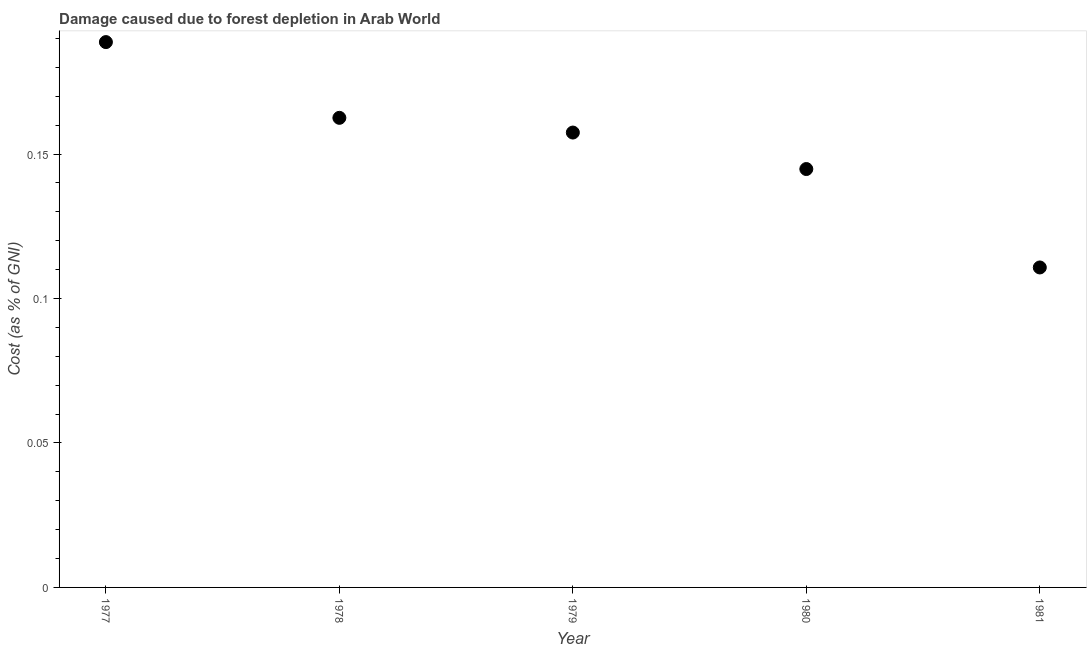What is the damage caused due to forest depletion in 1979?
Provide a succinct answer. 0.16. Across all years, what is the maximum damage caused due to forest depletion?
Offer a terse response. 0.19. Across all years, what is the minimum damage caused due to forest depletion?
Your response must be concise. 0.11. What is the sum of the damage caused due to forest depletion?
Provide a short and direct response. 0.76. What is the difference between the damage caused due to forest depletion in 1980 and 1981?
Keep it short and to the point. 0.03. What is the average damage caused due to forest depletion per year?
Offer a terse response. 0.15. What is the median damage caused due to forest depletion?
Your answer should be very brief. 0.16. What is the ratio of the damage caused due to forest depletion in 1977 to that in 1981?
Provide a short and direct response. 1.7. What is the difference between the highest and the second highest damage caused due to forest depletion?
Offer a terse response. 0.03. Is the sum of the damage caused due to forest depletion in 1978 and 1979 greater than the maximum damage caused due to forest depletion across all years?
Offer a very short reply. Yes. What is the difference between the highest and the lowest damage caused due to forest depletion?
Provide a short and direct response. 0.08. In how many years, is the damage caused due to forest depletion greater than the average damage caused due to forest depletion taken over all years?
Keep it short and to the point. 3. Does the damage caused due to forest depletion monotonically increase over the years?
Provide a short and direct response. No. How many dotlines are there?
Make the answer very short. 1. What is the difference between two consecutive major ticks on the Y-axis?
Offer a very short reply. 0.05. Are the values on the major ticks of Y-axis written in scientific E-notation?
Offer a very short reply. No. What is the title of the graph?
Offer a very short reply. Damage caused due to forest depletion in Arab World. What is the label or title of the Y-axis?
Your response must be concise. Cost (as % of GNI). What is the Cost (as % of GNI) in 1977?
Keep it short and to the point. 0.19. What is the Cost (as % of GNI) in 1978?
Your answer should be very brief. 0.16. What is the Cost (as % of GNI) in 1979?
Make the answer very short. 0.16. What is the Cost (as % of GNI) in 1980?
Provide a succinct answer. 0.14. What is the Cost (as % of GNI) in 1981?
Your response must be concise. 0.11. What is the difference between the Cost (as % of GNI) in 1977 and 1978?
Give a very brief answer. 0.03. What is the difference between the Cost (as % of GNI) in 1977 and 1979?
Ensure brevity in your answer.  0.03. What is the difference between the Cost (as % of GNI) in 1977 and 1980?
Make the answer very short. 0.04. What is the difference between the Cost (as % of GNI) in 1977 and 1981?
Keep it short and to the point. 0.08. What is the difference between the Cost (as % of GNI) in 1978 and 1979?
Your answer should be compact. 0.01. What is the difference between the Cost (as % of GNI) in 1978 and 1980?
Your answer should be compact. 0.02. What is the difference between the Cost (as % of GNI) in 1978 and 1981?
Provide a succinct answer. 0.05. What is the difference between the Cost (as % of GNI) in 1979 and 1980?
Your response must be concise. 0.01. What is the difference between the Cost (as % of GNI) in 1979 and 1981?
Offer a very short reply. 0.05. What is the difference between the Cost (as % of GNI) in 1980 and 1981?
Your answer should be very brief. 0.03. What is the ratio of the Cost (as % of GNI) in 1977 to that in 1978?
Your answer should be very brief. 1.16. What is the ratio of the Cost (as % of GNI) in 1977 to that in 1979?
Keep it short and to the point. 1.2. What is the ratio of the Cost (as % of GNI) in 1977 to that in 1980?
Ensure brevity in your answer.  1.3. What is the ratio of the Cost (as % of GNI) in 1977 to that in 1981?
Make the answer very short. 1.7. What is the ratio of the Cost (as % of GNI) in 1978 to that in 1979?
Make the answer very short. 1.03. What is the ratio of the Cost (as % of GNI) in 1978 to that in 1980?
Provide a succinct answer. 1.12. What is the ratio of the Cost (as % of GNI) in 1978 to that in 1981?
Provide a short and direct response. 1.47. What is the ratio of the Cost (as % of GNI) in 1979 to that in 1980?
Your answer should be compact. 1.09. What is the ratio of the Cost (as % of GNI) in 1979 to that in 1981?
Provide a succinct answer. 1.42. What is the ratio of the Cost (as % of GNI) in 1980 to that in 1981?
Make the answer very short. 1.31. 